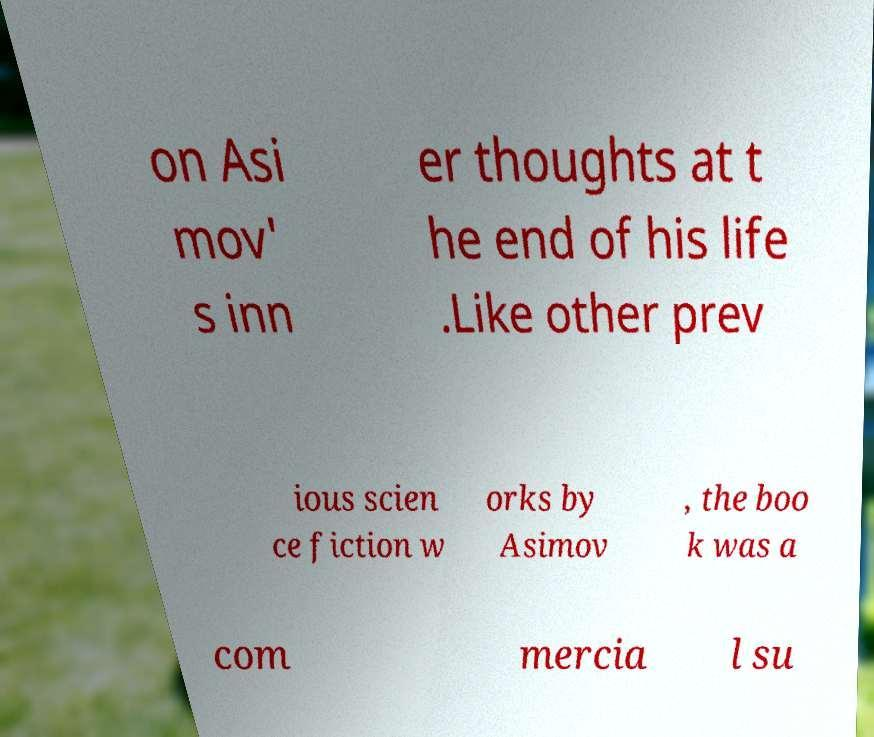Could you extract and type out the text from this image? on Asi mov' s inn er thoughts at t he end of his life .Like other prev ious scien ce fiction w orks by Asimov , the boo k was a com mercia l su 